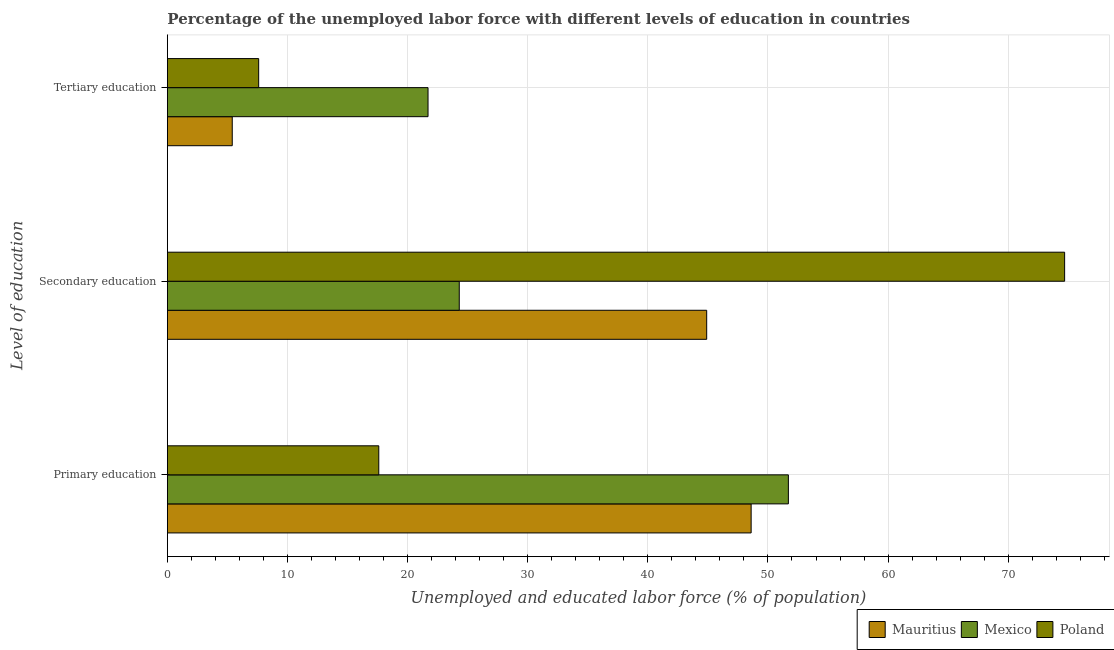How many groups of bars are there?
Provide a short and direct response. 3. Are the number of bars per tick equal to the number of legend labels?
Your answer should be compact. Yes. Are the number of bars on each tick of the Y-axis equal?
Make the answer very short. Yes. How many bars are there on the 3rd tick from the bottom?
Your answer should be very brief. 3. What is the percentage of labor force who received primary education in Poland?
Ensure brevity in your answer.  17.6. Across all countries, what is the maximum percentage of labor force who received secondary education?
Ensure brevity in your answer.  74.7. Across all countries, what is the minimum percentage of labor force who received secondary education?
Make the answer very short. 24.3. What is the total percentage of labor force who received tertiary education in the graph?
Provide a short and direct response. 34.7. What is the difference between the percentage of labor force who received tertiary education in Poland and that in Mauritius?
Provide a short and direct response. 2.2. What is the difference between the percentage of labor force who received secondary education in Mauritius and the percentage of labor force who received tertiary education in Mexico?
Provide a succinct answer. 23.2. What is the average percentage of labor force who received primary education per country?
Keep it short and to the point. 39.3. What is the difference between the percentage of labor force who received secondary education and percentage of labor force who received primary education in Mauritius?
Keep it short and to the point. -3.7. In how many countries, is the percentage of labor force who received secondary education greater than 4 %?
Make the answer very short. 3. What is the ratio of the percentage of labor force who received tertiary education in Mexico to that in Poland?
Your response must be concise. 2.86. Is the percentage of labor force who received secondary education in Mauritius less than that in Poland?
Your response must be concise. Yes. Is the difference between the percentage of labor force who received tertiary education in Mexico and Mauritius greater than the difference between the percentage of labor force who received secondary education in Mexico and Mauritius?
Give a very brief answer. Yes. What is the difference between the highest and the second highest percentage of labor force who received secondary education?
Offer a very short reply. 29.8. What is the difference between the highest and the lowest percentage of labor force who received secondary education?
Provide a succinct answer. 50.4. Is the sum of the percentage of labor force who received secondary education in Mauritius and Poland greater than the maximum percentage of labor force who received primary education across all countries?
Offer a terse response. Yes. What does the 2nd bar from the top in Tertiary education represents?
Provide a short and direct response. Mexico. What does the 1st bar from the bottom in Primary education represents?
Make the answer very short. Mauritius. Is it the case that in every country, the sum of the percentage of labor force who received primary education and percentage of labor force who received secondary education is greater than the percentage of labor force who received tertiary education?
Your answer should be compact. Yes. Are all the bars in the graph horizontal?
Give a very brief answer. Yes. What is the difference between two consecutive major ticks on the X-axis?
Your answer should be very brief. 10. Does the graph contain any zero values?
Your response must be concise. No. Does the graph contain grids?
Ensure brevity in your answer.  Yes. How many legend labels are there?
Provide a succinct answer. 3. How are the legend labels stacked?
Give a very brief answer. Horizontal. What is the title of the graph?
Give a very brief answer. Percentage of the unemployed labor force with different levels of education in countries. Does "Kazakhstan" appear as one of the legend labels in the graph?
Provide a succinct answer. No. What is the label or title of the X-axis?
Your answer should be very brief. Unemployed and educated labor force (% of population). What is the label or title of the Y-axis?
Keep it short and to the point. Level of education. What is the Unemployed and educated labor force (% of population) of Mauritius in Primary education?
Offer a terse response. 48.6. What is the Unemployed and educated labor force (% of population) of Mexico in Primary education?
Make the answer very short. 51.7. What is the Unemployed and educated labor force (% of population) in Poland in Primary education?
Make the answer very short. 17.6. What is the Unemployed and educated labor force (% of population) of Mauritius in Secondary education?
Offer a terse response. 44.9. What is the Unemployed and educated labor force (% of population) of Mexico in Secondary education?
Your answer should be compact. 24.3. What is the Unemployed and educated labor force (% of population) of Poland in Secondary education?
Ensure brevity in your answer.  74.7. What is the Unemployed and educated labor force (% of population) in Mauritius in Tertiary education?
Keep it short and to the point. 5.4. What is the Unemployed and educated labor force (% of population) of Mexico in Tertiary education?
Your response must be concise. 21.7. What is the Unemployed and educated labor force (% of population) in Poland in Tertiary education?
Keep it short and to the point. 7.6. Across all Level of education, what is the maximum Unemployed and educated labor force (% of population) of Mauritius?
Give a very brief answer. 48.6. Across all Level of education, what is the maximum Unemployed and educated labor force (% of population) of Mexico?
Keep it short and to the point. 51.7. Across all Level of education, what is the maximum Unemployed and educated labor force (% of population) in Poland?
Offer a very short reply. 74.7. Across all Level of education, what is the minimum Unemployed and educated labor force (% of population) of Mauritius?
Ensure brevity in your answer.  5.4. Across all Level of education, what is the minimum Unemployed and educated labor force (% of population) of Mexico?
Make the answer very short. 21.7. Across all Level of education, what is the minimum Unemployed and educated labor force (% of population) of Poland?
Your response must be concise. 7.6. What is the total Unemployed and educated labor force (% of population) of Mauritius in the graph?
Ensure brevity in your answer.  98.9. What is the total Unemployed and educated labor force (% of population) of Mexico in the graph?
Give a very brief answer. 97.7. What is the total Unemployed and educated labor force (% of population) in Poland in the graph?
Offer a terse response. 99.9. What is the difference between the Unemployed and educated labor force (% of population) in Mexico in Primary education and that in Secondary education?
Keep it short and to the point. 27.4. What is the difference between the Unemployed and educated labor force (% of population) of Poland in Primary education and that in Secondary education?
Provide a succinct answer. -57.1. What is the difference between the Unemployed and educated labor force (% of population) in Mauritius in Primary education and that in Tertiary education?
Provide a short and direct response. 43.2. What is the difference between the Unemployed and educated labor force (% of population) of Mexico in Primary education and that in Tertiary education?
Provide a short and direct response. 30. What is the difference between the Unemployed and educated labor force (% of population) of Mauritius in Secondary education and that in Tertiary education?
Ensure brevity in your answer.  39.5. What is the difference between the Unemployed and educated labor force (% of population) in Poland in Secondary education and that in Tertiary education?
Keep it short and to the point. 67.1. What is the difference between the Unemployed and educated labor force (% of population) of Mauritius in Primary education and the Unemployed and educated labor force (% of population) of Mexico in Secondary education?
Offer a very short reply. 24.3. What is the difference between the Unemployed and educated labor force (% of population) of Mauritius in Primary education and the Unemployed and educated labor force (% of population) of Poland in Secondary education?
Provide a succinct answer. -26.1. What is the difference between the Unemployed and educated labor force (% of population) in Mauritius in Primary education and the Unemployed and educated labor force (% of population) in Mexico in Tertiary education?
Offer a terse response. 26.9. What is the difference between the Unemployed and educated labor force (% of population) in Mauritius in Primary education and the Unemployed and educated labor force (% of population) in Poland in Tertiary education?
Offer a very short reply. 41. What is the difference between the Unemployed and educated labor force (% of population) in Mexico in Primary education and the Unemployed and educated labor force (% of population) in Poland in Tertiary education?
Offer a terse response. 44.1. What is the difference between the Unemployed and educated labor force (% of population) in Mauritius in Secondary education and the Unemployed and educated labor force (% of population) in Mexico in Tertiary education?
Keep it short and to the point. 23.2. What is the difference between the Unemployed and educated labor force (% of population) in Mauritius in Secondary education and the Unemployed and educated labor force (% of population) in Poland in Tertiary education?
Your response must be concise. 37.3. What is the difference between the Unemployed and educated labor force (% of population) in Mexico in Secondary education and the Unemployed and educated labor force (% of population) in Poland in Tertiary education?
Provide a short and direct response. 16.7. What is the average Unemployed and educated labor force (% of population) in Mauritius per Level of education?
Offer a terse response. 32.97. What is the average Unemployed and educated labor force (% of population) in Mexico per Level of education?
Your answer should be very brief. 32.57. What is the average Unemployed and educated labor force (% of population) in Poland per Level of education?
Your answer should be compact. 33.3. What is the difference between the Unemployed and educated labor force (% of population) in Mauritius and Unemployed and educated labor force (% of population) in Mexico in Primary education?
Give a very brief answer. -3.1. What is the difference between the Unemployed and educated labor force (% of population) of Mauritius and Unemployed and educated labor force (% of population) of Poland in Primary education?
Provide a succinct answer. 31. What is the difference between the Unemployed and educated labor force (% of population) in Mexico and Unemployed and educated labor force (% of population) in Poland in Primary education?
Ensure brevity in your answer.  34.1. What is the difference between the Unemployed and educated labor force (% of population) in Mauritius and Unemployed and educated labor force (% of population) in Mexico in Secondary education?
Your response must be concise. 20.6. What is the difference between the Unemployed and educated labor force (% of population) in Mauritius and Unemployed and educated labor force (% of population) in Poland in Secondary education?
Make the answer very short. -29.8. What is the difference between the Unemployed and educated labor force (% of population) in Mexico and Unemployed and educated labor force (% of population) in Poland in Secondary education?
Your answer should be compact. -50.4. What is the difference between the Unemployed and educated labor force (% of population) in Mauritius and Unemployed and educated labor force (% of population) in Mexico in Tertiary education?
Offer a terse response. -16.3. What is the difference between the Unemployed and educated labor force (% of population) of Mauritius and Unemployed and educated labor force (% of population) of Poland in Tertiary education?
Offer a terse response. -2.2. What is the difference between the Unemployed and educated labor force (% of population) of Mexico and Unemployed and educated labor force (% of population) of Poland in Tertiary education?
Keep it short and to the point. 14.1. What is the ratio of the Unemployed and educated labor force (% of population) of Mauritius in Primary education to that in Secondary education?
Your answer should be very brief. 1.08. What is the ratio of the Unemployed and educated labor force (% of population) of Mexico in Primary education to that in Secondary education?
Ensure brevity in your answer.  2.13. What is the ratio of the Unemployed and educated labor force (% of population) in Poland in Primary education to that in Secondary education?
Give a very brief answer. 0.24. What is the ratio of the Unemployed and educated labor force (% of population) of Mexico in Primary education to that in Tertiary education?
Your response must be concise. 2.38. What is the ratio of the Unemployed and educated labor force (% of population) in Poland in Primary education to that in Tertiary education?
Offer a terse response. 2.32. What is the ratio of the Unemployed and educated labor force (% of population) in Mauritius in Secondary education to that in Tertiary education?
Your answer should be very brief. 8.31. What is the ratio of the Unemployed and educated labor force (% of population) in Mexico in Secondary education to that in Tertiary education?
Provide a short and direct response. 1.12. What is the ratio of the Unemployed and educated labor force (% of population) of Poland in Secondary education to that in Tertiary education?
Provide a succinct answer. 9.83. What is the difference between the highest and the second highest Unemployed and educated labor force (% of population) in Mauritius?
Your answer should be very brief. 3.7. What is the difference between the highest and the second highest Unemployed and educated labor force (% of population) of Mexico?
Offer a terse response. 27.4. What is the difference between the highest and the second highest Unemployed and educated labor force (% of population) in Poland?
Give a very brief answer. 57.1. What is the difference between the highest and the lowest Unemployed and educated labor force (% of population) of Mauritius?
Your response must be concise. 43.2. What is the difference between the highest and the lowest Unemployed and educated labor force (% of population) in Poland?
Offer a very short reply. 67.1. 